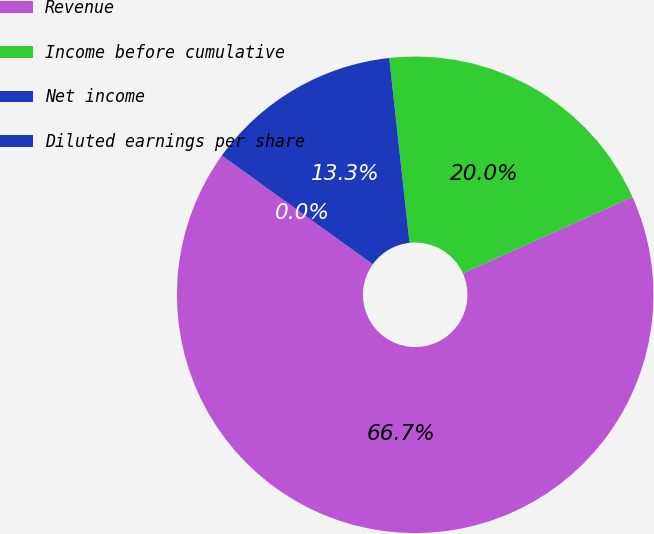Convert chart to OTSL. <chart><loc_0><loc_0><loc_500><loc_500><pie_chart><fcel>Revenue<fcel>Income before cumulative<fcel>Net income<fcel>Diluted earnings per share<nl><fcel>66.67%<fcel>20.0%<fcel>13.33%<fcel>0.0%<nl></chart> 